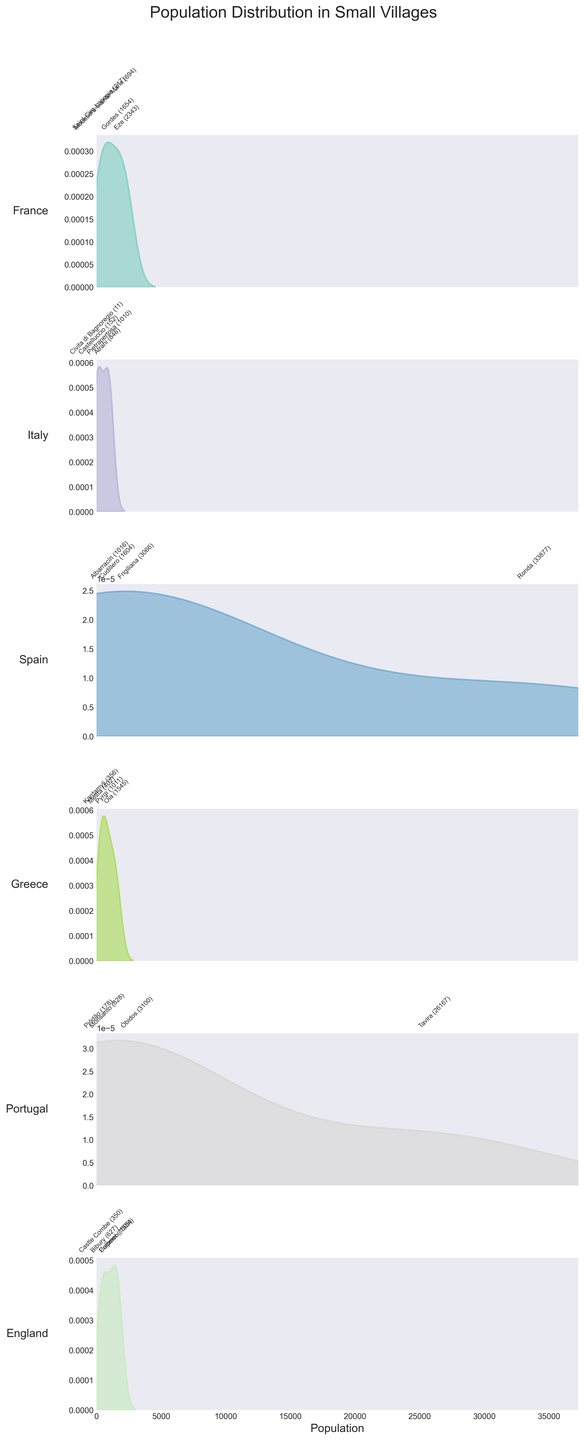What is the title of the figure? The title of the figure is displayed prominently at the top and is usually larger in font size compared to other text on the plot. It helps provide a general understanding of what the figure illustrates.
Answer: Population Distribution in Small Villages Which country has the village with the smallest population, and what is that population? Look for the density plot that represents the smallest value along the x-axis. Identify the village annotated with this value.
Answer: Italy, Civita di Bagnoregio (11) How many countries are represented in the figure? Count the number of subplots, each of which corresponds to a different country.
Answer: 5 Which village has the largest population, and what is that population? Find the density plot with the highest population value along the x-axis, and identify the corresponding village.
Answer: England, Ronda (33,877) Among the countries, which one has the broadest range of village populations? Compare the width of the density plots along the x-axis for each country. The broader the plot, the wider the range of population sizes.
Answer: Portugal For the villages in France, which one has the highest population? Look within the density plot representing France and identify the village name associated with the highest population peak.
Answer: Eze (2,343) Which country has the highest density peak on the density plot? Identify the subplot where the peak of the density plot is the tallest. This indicates the highest density of populations around a certain size.
Answer: England (multiple high peaks) What is the approximate population range for villages in Greece? Look at the density plot for Greece and identify the minimum and maximum x-values where the distribution extends.
Answer: 356 to 1,545 Which village in Portugal has a population closest to 3,100? In the density plot for Portugal, find the population annotations and identify the village near the value of 3,100.
Answer: Óbidos Is there any overlap in the population sizes of villages in Italy and Spain? Compare the x-axis ranges of the density plots for Italy and Spain. Check if there are any common values that both distributions span.
Answer: Yes 